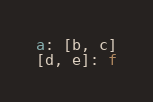<code> <loc_0><loc_0><loc_500><loc_500><_YAML_>a: [b, c]
[d, e]: f
</code> 